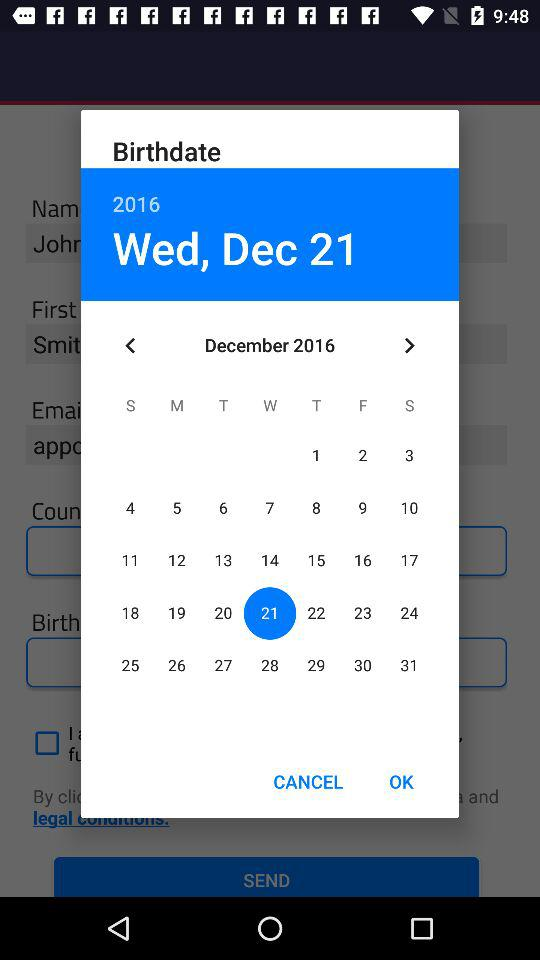What is the birthdate? The birthdate is Wednesday, December 21, 2016. 